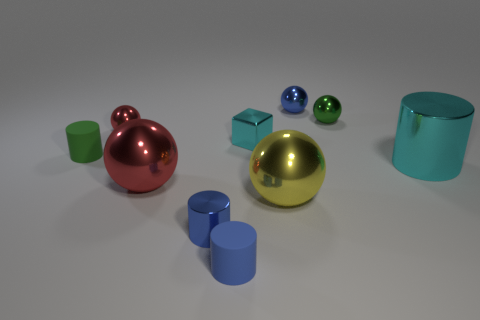Could you tell me which objects in this image are the smallest and what color they are? The smallest objects in the image are the two glossy spheres; one is blue and the other is green. Could you tell if there's any pattern or symmetry in the arrangement of these objects? The objects are arranged with no clear pattern or symmetry. Their placement appears random, with varying distances and no discernible sequence or alignment. 